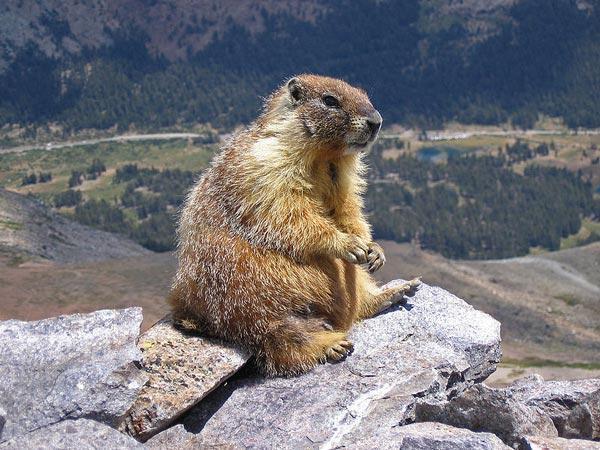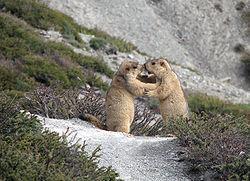The first image is the image on the left, the second image is the image on the right. Considering the images on both sides, is "Two animals are playing with each other in the image on the right." valid? Answer yes or no. Yes. 